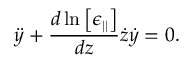<formula> <loc_0><loc_0><loc_500><loc_500>\ddot { y } + \frac { d \ln \left [ \epsilon _ { | | } \right ] } { d z } \dot { z } \dot { y } = 0 .</formula> 